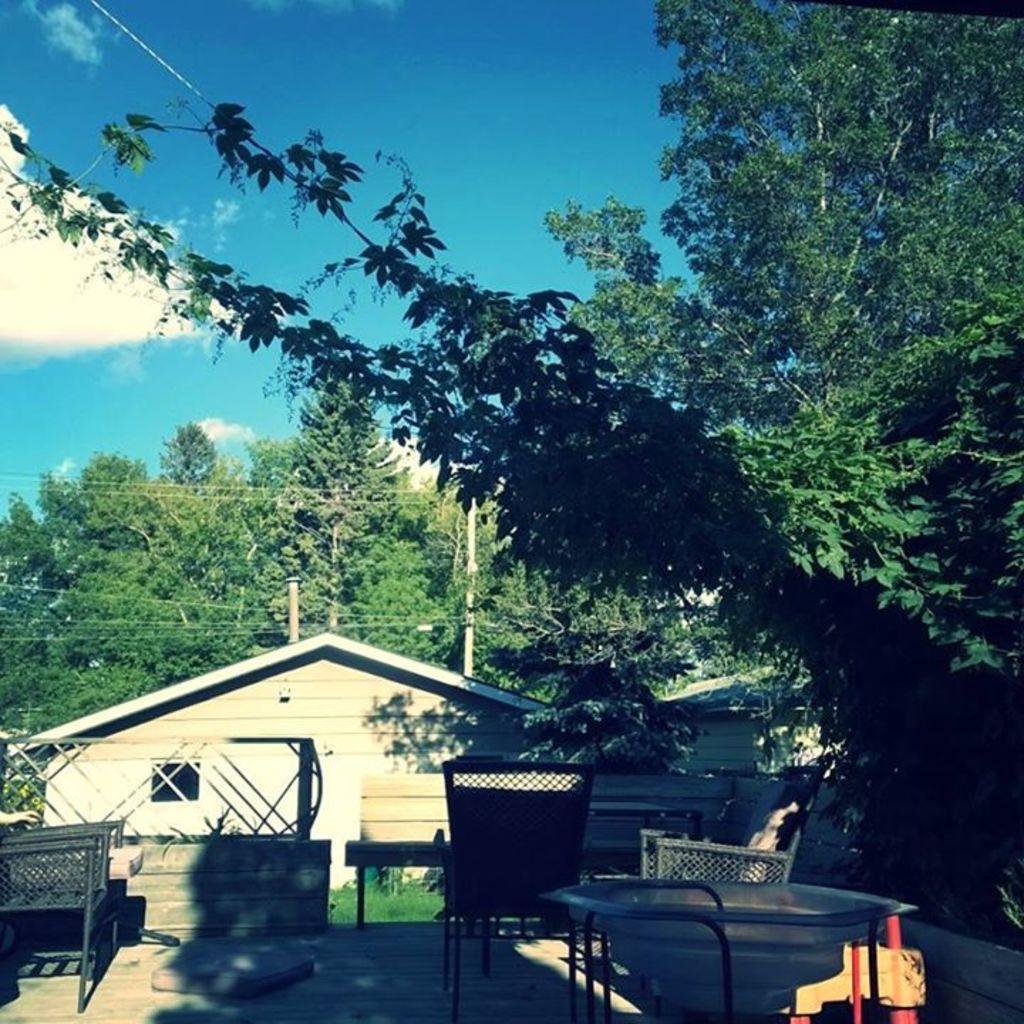Can you describe this image briefly? In this image we can see tables, chairs, wall, grass, sheds, poles, and trees. In the background there is sky with clouds. 